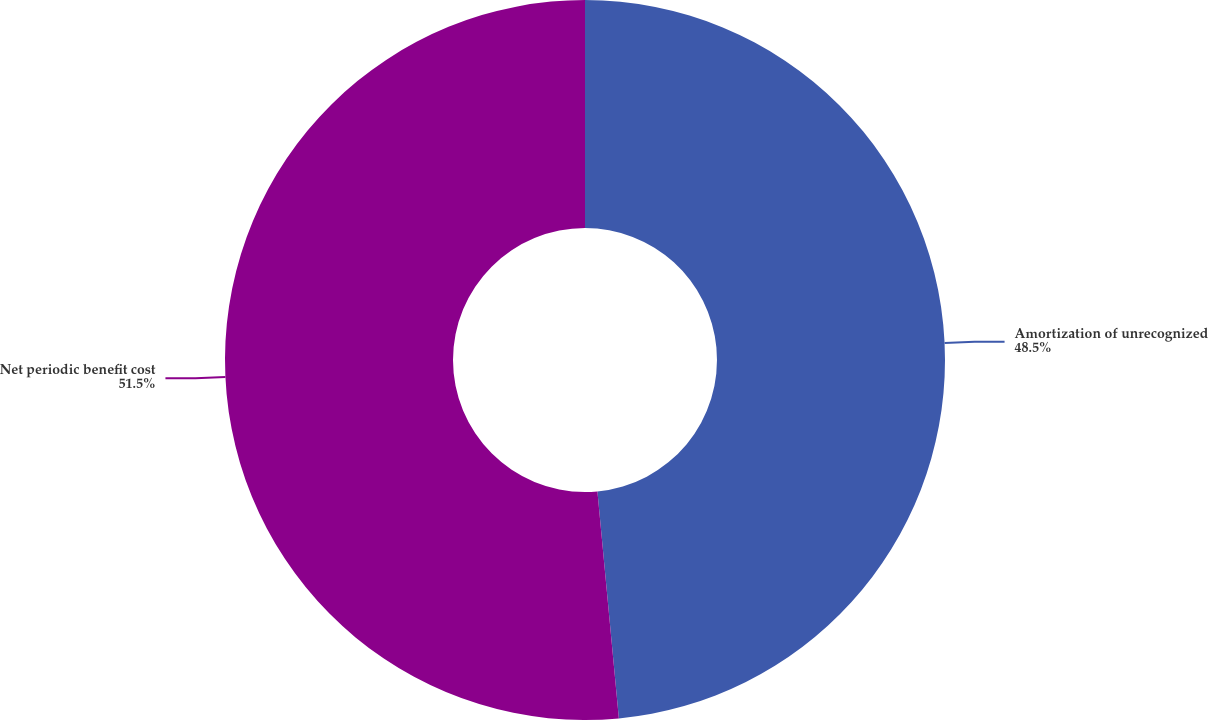Convert chart. <chart><loc_0><loc_0><loc_500><loc_500><pie_chart><fcel>Amortization of unrecognized<fcel>Net periodic benefit cost<nl><fcel>48.5%<fcel>51.5%<nl></chart> 